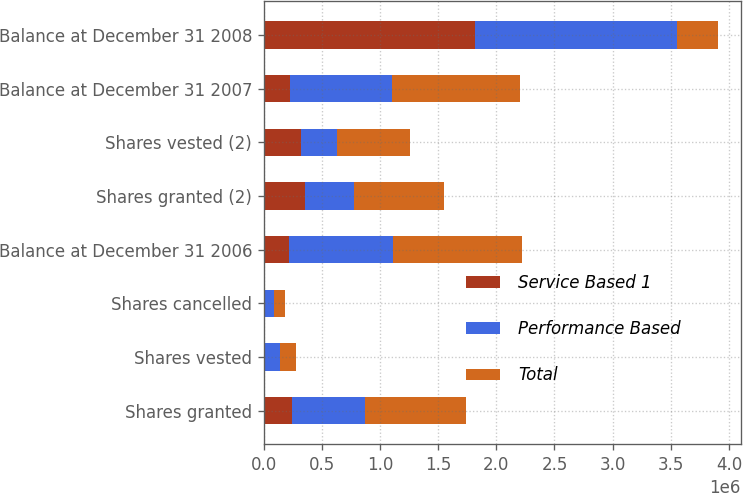Convert chart to OTSL. <chart><loc_0><loc_0><loc_500><loc_500><stacked_bar_chart><ecel><fcel>Shares granted<fcel>Shares vested<fcel>Shares cancelled<fcel>Balance at December 31 2006<fcel>Shares granted (2)<fcel>Shares vested (2)<fcel>Balance at December 31 2007<fcel>Balance at December 31 2008<nl><fcel>Service Based 1<fcel>242015<fcel>8100<fcel>14460<fcel>219455<fcel>350809<fcel>318864<fcel>228576<fcel>1.81719e+06<nl><fcel>Performance Based<fcel>626672<fcel>130793<fcel>75765<fcel>889954<fcel>422980<fcel>311033<fcel>872558<fcel>1.7367e+06<nl><fcel>Total<fcel>868687<fcel>138893<fcel>90225<fcel>1.10941e+06<fcel>773789<fcel>629897<fcel>1.10113e+06<fcel>350809<nl></chart> 